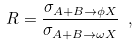<formula> <loc_0><loc_0><loc_500><loc_500>R = \frac { \sigma _ { A + B \to \phi X } } { \sigma _ { A + B \to \omega X } } \ ,</formula> 